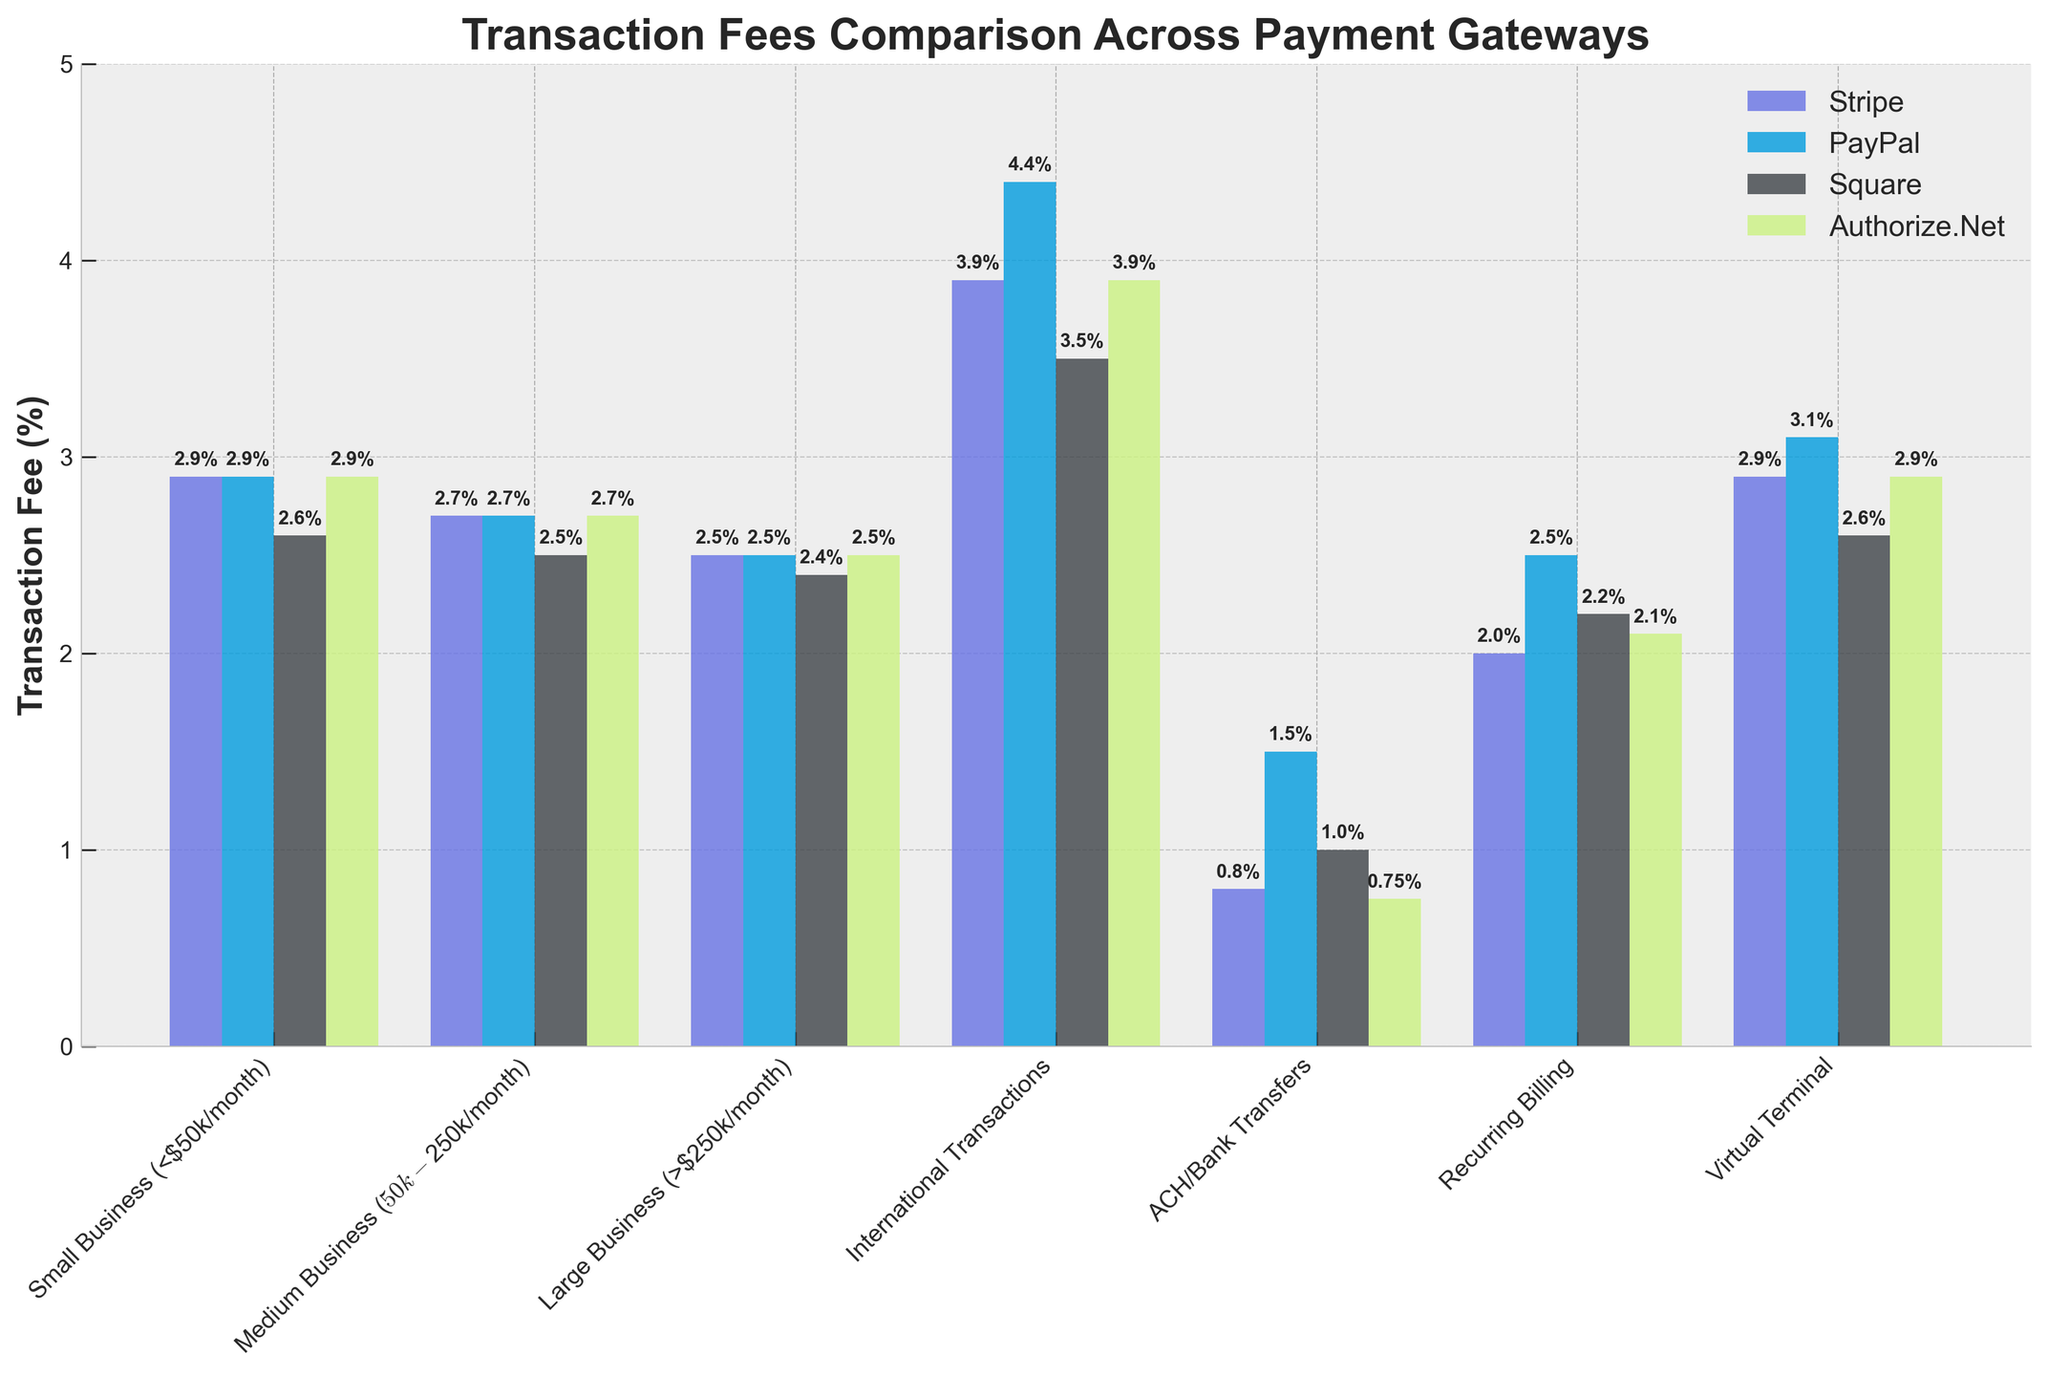Which payment gateway has the highest fee for international transactions? By looking at the bar heights for international transactions, the tallest bar is for PayPal.
Answer: PayPal What is the difference in transaction fees between a small business and a large business using Stripe? The transaction fee for a small business using Stripe is 2.9%, while for a large business it is 2.5%. The difference is 2.9% - 2.5% = 0.4%.
Answer: 0.4% Which payment gateway offers the lowest fee for ACH/Bank Transfers? For ACH/Bank Transfers, the shortest bar corresponds to Authorize.Net with a fee of 0.75%.
Answer: Authorize.Net Among Recurring Billing, which gateway charges the highest fee? By comparing the heights of the bars for Recurring Billing, the tallest bar is for PayPal with a fee of 2.5%.
Answer: PayPal What is the average transaction fee for a medium business across all gateways? The fees for a medium business are 2.7% (Stripe), 2.7% (PayPal), 2.5% (Square), and 2.7% (Authorize.Net). The average is (2.7 + 2.7 + 2.5 + 2.7) / 4 = 2.65%.
Answer: 2.65% Does Square charge more or less than PayPal for virtual terminal transactions? By comparing the heights of the bars for virtual terminal transactions, Square's fee is 2.6% and PayPal's is 3.1%. Square charges less than PayPal.
Answer: Less What is the combined fee of Stripe for a small business and a virtual terminal transaction? The fee for a small business is 2.9%, and for a virtual terminal transaction, it is also 2.9%. The combined fee is 2.9% + 2.9% = 5.8%.
Answer: 5.8% Which payment gateway has the least variation in fees across different transaction types? By observing the relative consistency of bar heights across different transaction types, Stripe and Authorize.Net show the least variation in fees.
Answer: Stripe, Authorize.Net How much more does PayPal charge for international transactions compared to Square? PayPal charges 4.4% for international transactions, and Square charges 3.5%. The difference is 4.4% - 3.5% = 0.9%.
Answer: 0.9% 